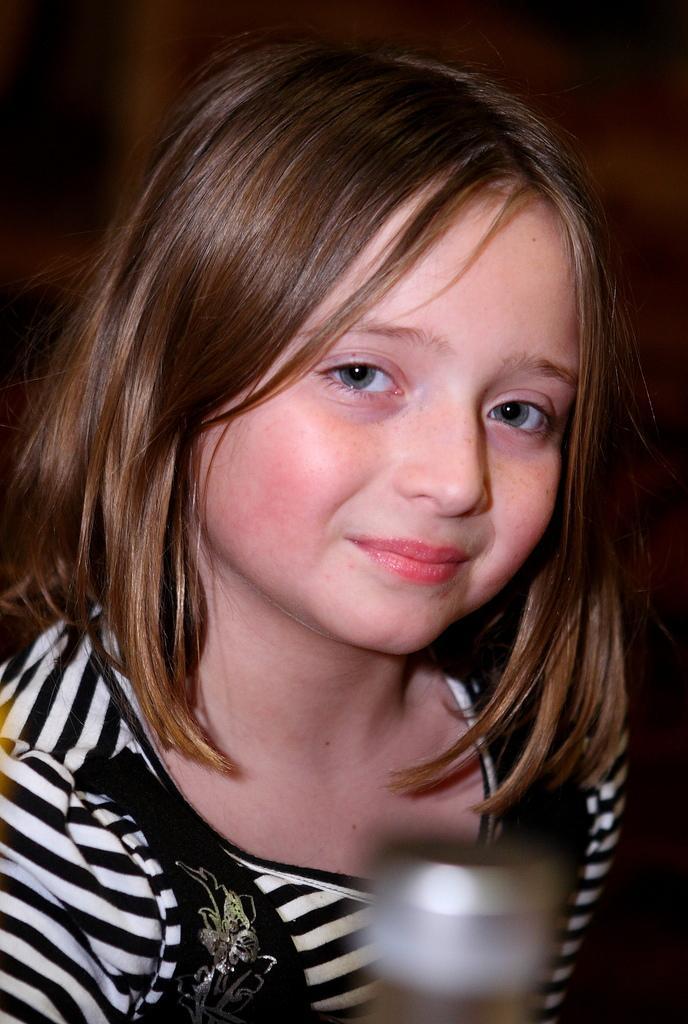Describe this image in one or two sentences. In this image we can see a girl wearing black and white color dress is smiling. The background of the image is dark and this part of the image is slightly blurred. 